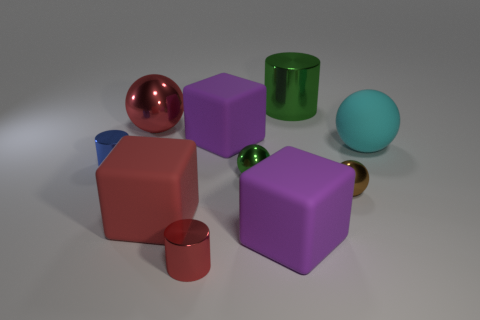What can you infer about the setting based on the arrangement of the objects? The orderly arrangement of the objects against a neutral background suggests a controlled setting, perhaps a studio setup designed to focus attention on the shapes and materials of the objects without any distractions. Do the objects have any identifying marks or features? No, the objects are devoid of any distinguishing marks or features, which implies they might be generic geometric shapes used for educational or demonstrational purposes, focusing solely on their form and material. 